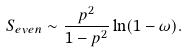<formula> <loc_0><loc_0><loc_500><loc_500>S _ { e v e n } \sim \frac { p ^ { 2 } } { 1 - p ^ { 2 } } \ln ( 1 - \omega ) .</formula> 